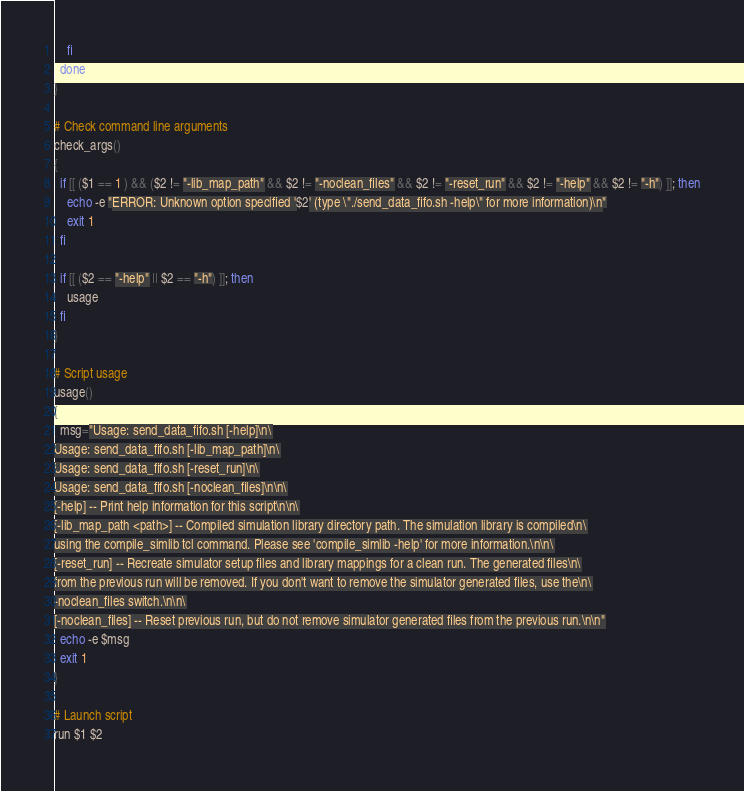Convert code to text. <code><loc_0><loc_0><loc_500><loc_500><_Bash_>    fi
  done
}

# Check command line arguments
check_args()
{
  if [[ ($1 == 1 ) && ($2 != "-lib_map_path" && $2 != "-noclean_files" && $2 != "-reset_run" && $2 != "-help" && $2 != "-h") ]]; then
    echo -e "ERROR: Unknown option specified '$2' (type \"./send_data_fifo.sh -help\" for more information)\n"
    exit 1
  fi

  if [[ ($2 == "-help" || $2 == "-h") ]]; then
    usage
  fi
}

# Script usage
usage()
{
  msg="Usage: send_data_fifo.sh [-help]\n\
Usage: send_data_fifo.sh [-lib_map_path]\n\
Usage: send_data_fifo.sh [-reset_run]\n\
Usage: send_data_fifo.sh [-noclean_files]\n\n\
[-help] -- Print help information for this script\n\n\
[-lib_map_path <path>] -- Compiled simulation library directory path. The simulation library is compiled\n\
using the compile_simlib tcl command. Please see 'compile_simlib -help' for more information.\n\n\
[-reset_run] -- Recreate simulator setup files and library mappings for a clean run. The generated files\n\
from the previous run will be removed. If you don't want to remove the simulator generated files, use the\n\
-noclean_files switch.\n\n\
[-noclean_files] -- Reset previous run, but do not remove simulator generated files from the previous run.\n\n"
  echo -e $msg
  exit 1
}

# Launch script
run $1 $2
</code> 